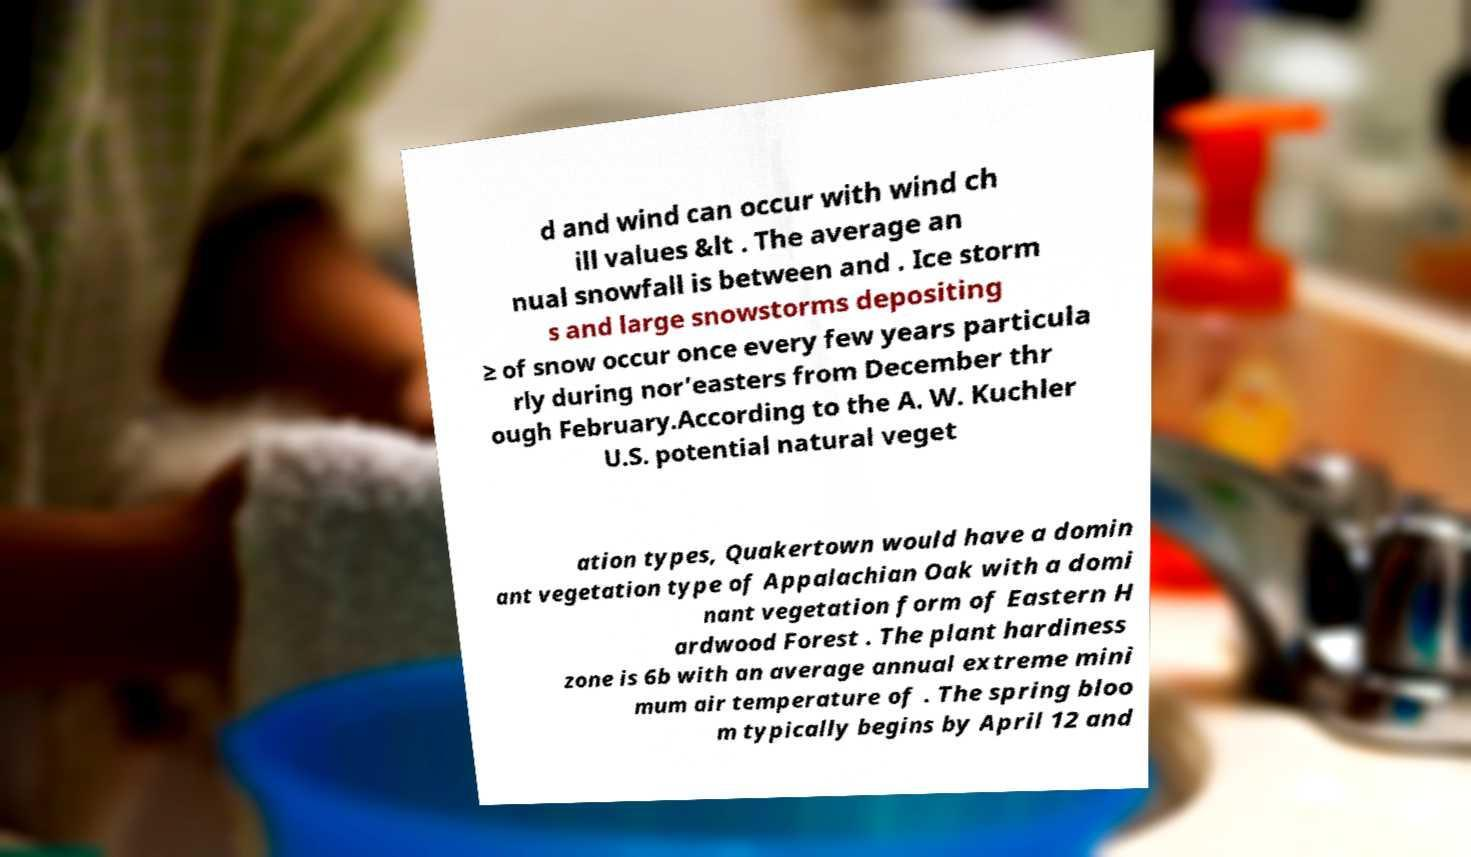I need the written content from this picture converted into text. Can you do that? d and wind can occur with wind ch ill values &lt . The average an nual snowfall is between and . Ice storm s and large snowstorms depositing ≥ of snow occur once every few years particula rly during nor’easters from December thr ough February.According to the A. W. Kuchler U.S. potential natural veget ation types, Quakertown would have a domin ant vegetation type of Appalachian Oak with a domi nant vegetation form of Eastern H ardwood Forest . The plant hardiness zone is 6b with an average annual extreme mini mum air temperature of . The spring bloo m typically begins by April 12 and 